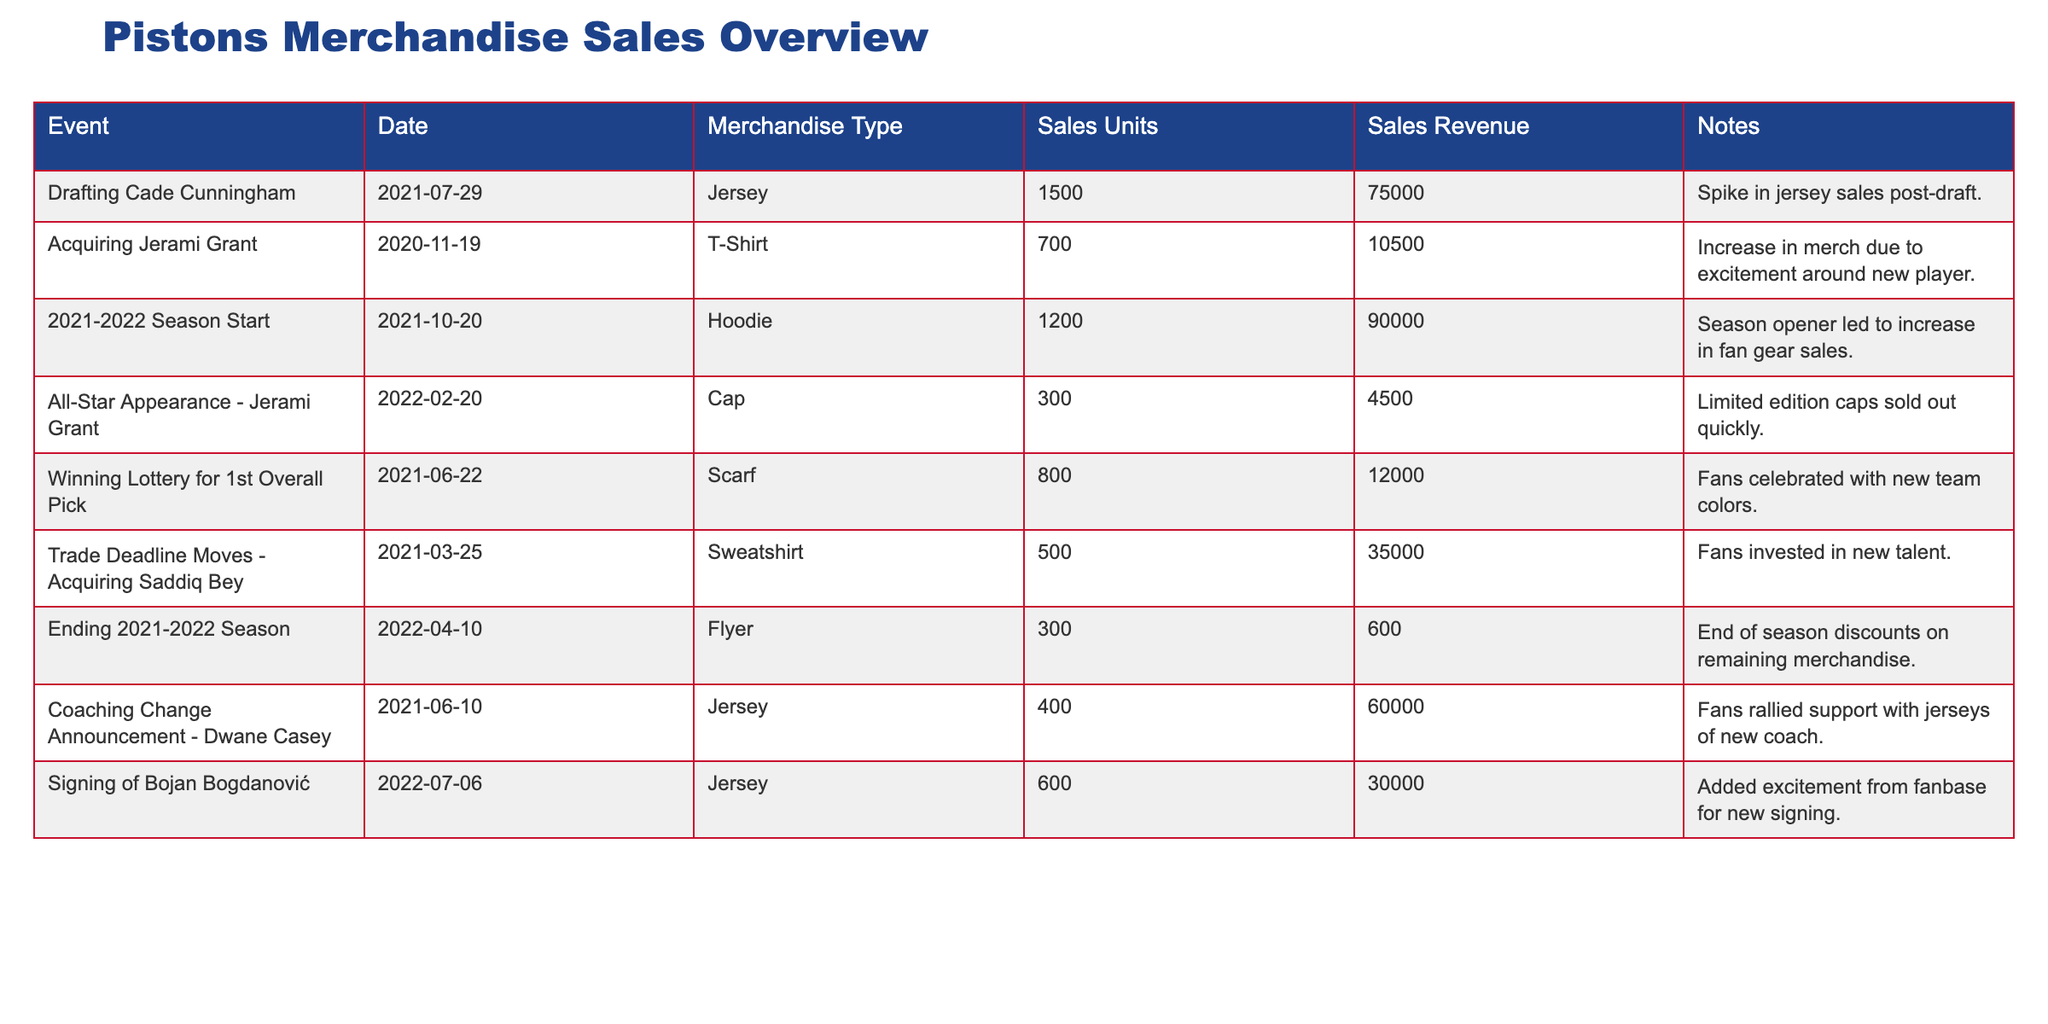What event led to the largest unit sales of merchandise? The highest sales units were recorded when the Pistons drafted Cade Cunningham, with 1500 jerseys sold. This value is clearly stated in the table.
Answer: 1500 How much revenue was generated from the sales of hoodies at the start of the 2021-2022 season? The table indicates that 1200 hoodies were sold for a revenue of 90000. Thus, the revenue generated from hoodies is 90000.
Answer: 90000 Did the acquiring of Jerami Grant lead to an increase in merchandise sales? Yes, there is a note associated with the event stating there was an increase in merchandise due to excitement around the new player, indicating a positive impact on sales.
Answer: Yes What was the total sales revenue generated from jerseys sold during the drafting of Cade Cunningham and the signing of Bojan Bogdanović? For Cade Cunningham, the sales revenue was 75000 from 1500 jerseys, and for Bojan Bogdanović, it was 30000 from 600 jerseys. Adding these: 75000 + 30000 = 105000.
Answer: 105000 Which merchandise type had the lowest sales in terms of units sold? The lowest sales in terms of units sold were for the sweatshirts, with only 500 sold. This is deduced from the sales units column.
Answer: 500 What percentage of total sales revenue came from the hoodie sales at the beginning of the 2021-2022 season, given total revenue from the table? The total revenue from all entries is 75000 + 10500 + 90000 + 4500 + 12000 + 35000 + 600 + 60000 + 30000 = 224600. The hoodie revenue was 90000, so the percentage is (90000 / 224600) * 100 ≈ 40.03%.
Answer: 40.03% Was there any event that generated fewer than 300 sales units? Yes, the event "Ending 2021-2022 Season" had 300 sales units, specifically for flyers, which is equal. However, no other event listed fewer than this, confirming the uniqueness of this data point within the given context.
Answer: Yes From the data, what was the average number of sales units across all merchandise types? To find the average, we first sum the sales units: 1500 + 700 + 1200 + 300 + 800 + 500 + 300 + 400 + 600 = 5100. The number of events is 9. Therefore, the average is 5100 / 9 ≈ 566.67.
Answer: 566.67 How many events yielded sales revenue greater than 40000? By checking the sales revenue in the table, we find three events: Drafting Cade Cunningham (75000), hoodie sales (90000), and the sweatshirt sales (35000 still fall below). Thus, only two events generated revenue greater than 40000.
Answer: 2 